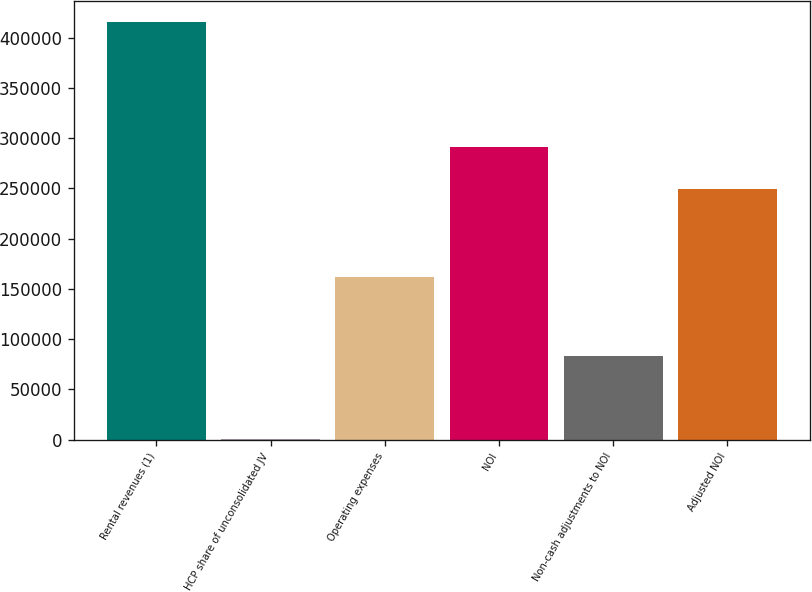<chart> <loc_0><loc_0><loc_500><loc_500><bar_chart><fcel>Rental revenues (1)<fcel>HCP share of unconsolidated JV<fcel>Operating expenses<fcel>NOI<fcel>Non-cash adjustments to NOI<fcel>Adjusted NOI<nl><fcel>415351<fcel>612<fcel>162054<fcel>291096<fcel>83559.8<fcel>249622<nl></chart> 